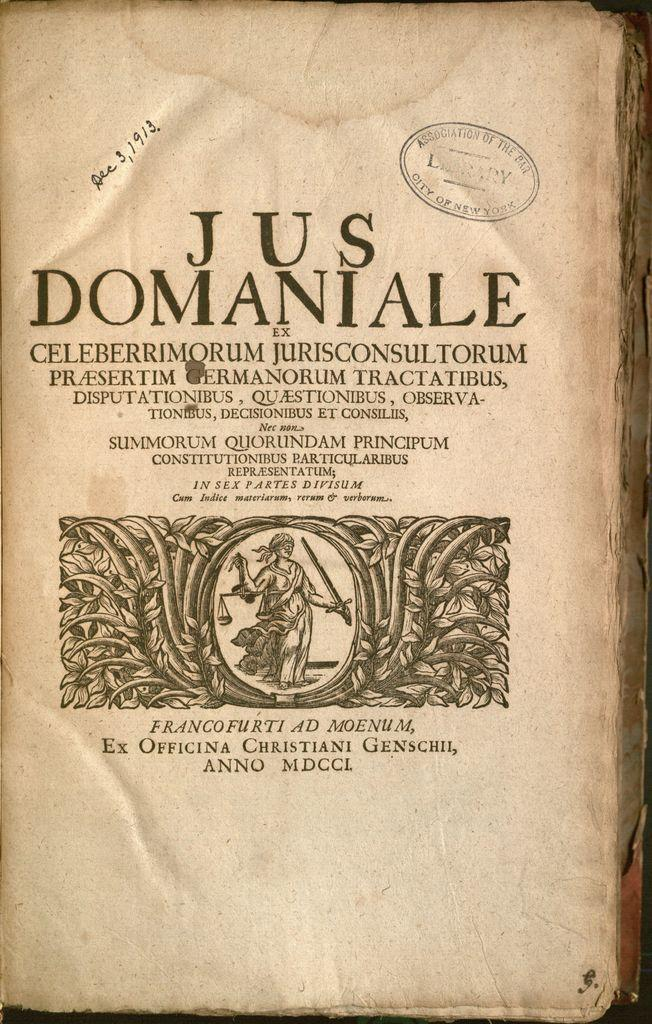<image>
Summarize the visual content of the image. a book with the word Jus at the top 